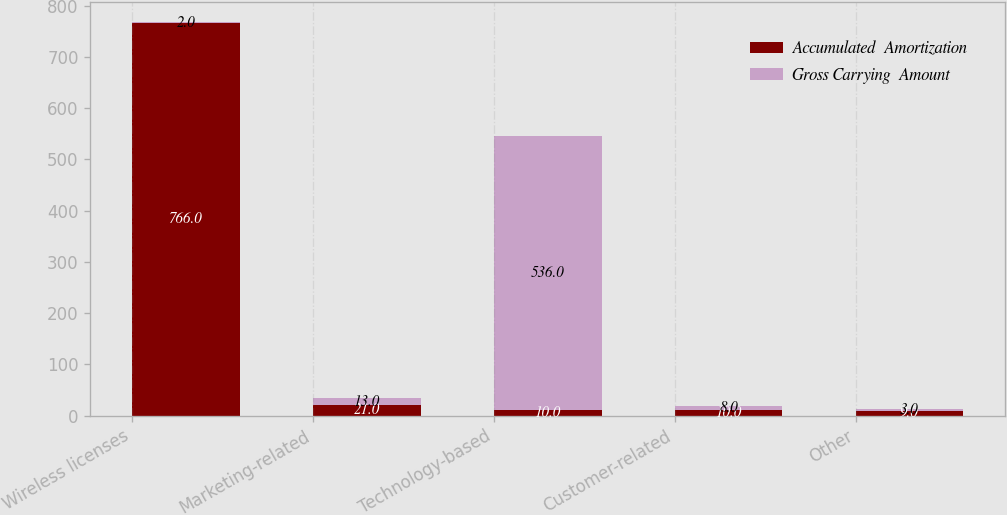Convert chart to OTSL. <chart><loc_0><loc_0><loc_500><loc_500><stacked_bar_chart><ecel><fcel>Wireless licenses<fcel>Marketing-related<fcel>Technology-based<fcel>Customer-related<fcel>Other<nl><fcel>Accumulated  Amortization<fcel>766<fcel>21<fcel>10<fcel>10<fcel>9<nl><fcel>Gross Carrying  Amount<fcel>2<fcel>13<fcel>536<fcel>8<fcel>3<nl></chart> 